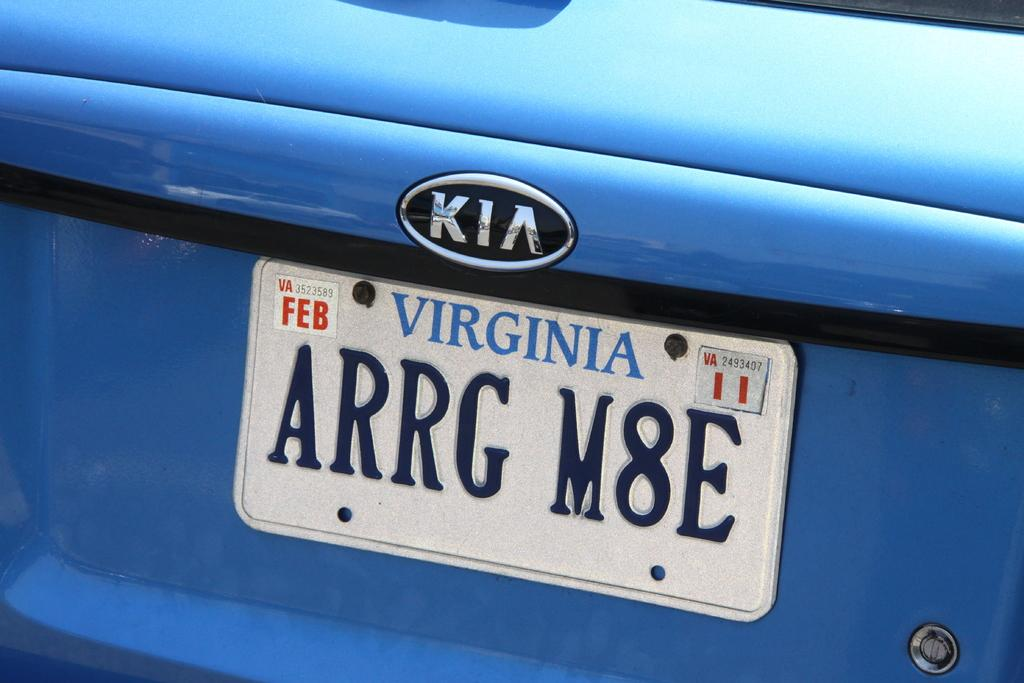<image>
Offer a succinct explanation of the picture presented. The blue KIA has license plate ARRG M8E and is registered in Virginia. 